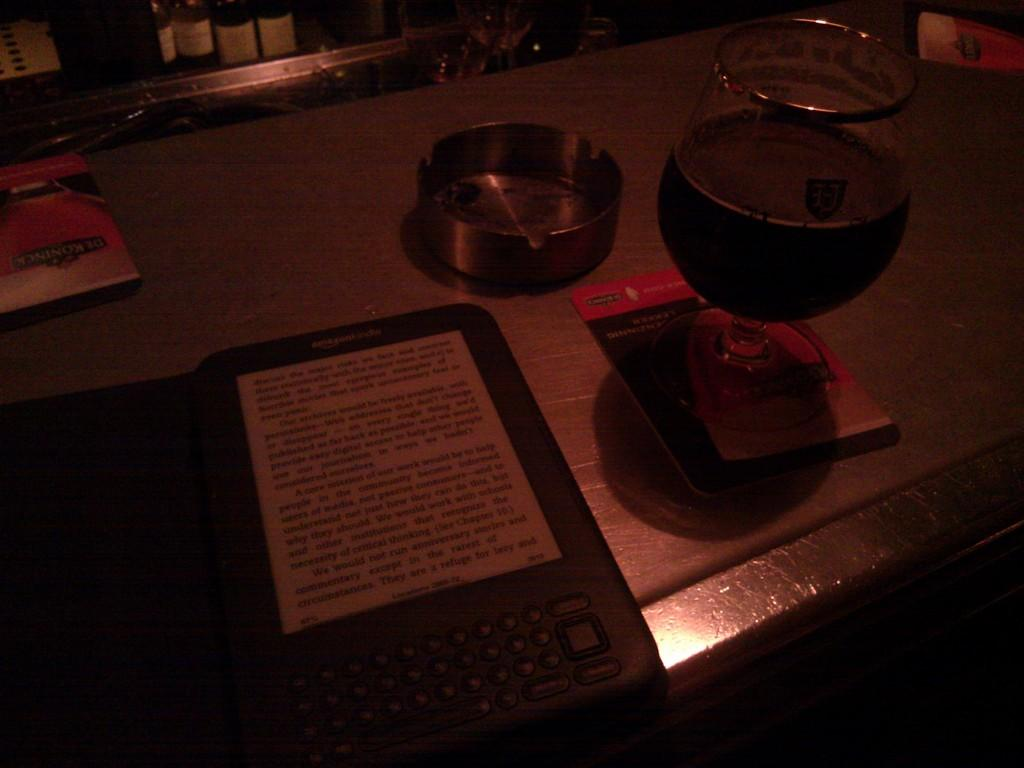What piece of furniture is present in the image? There is a table in the image. What is placed on the table? There is a glass, a bowl, and a toy mobile on the table. Can you describe the glass on the table? The facts provided do not give any details about the glass, so we cannot describe it further. What type of dust can be seen on the roof in the image? There is no mention of dust or a roof in the provided facts, so we cannot answer this question. 